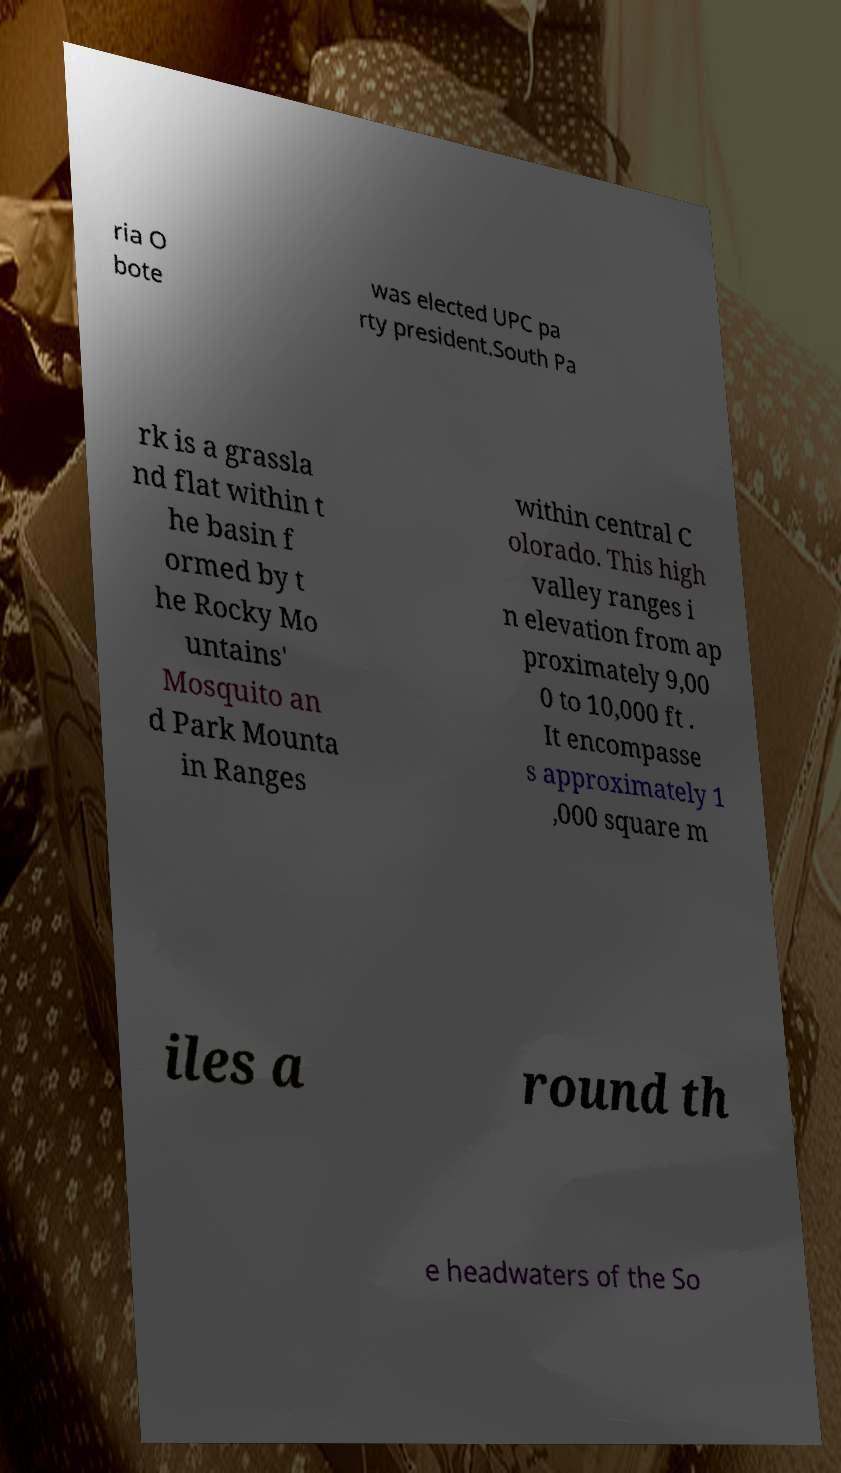I need the written content from this picture converted into text. Can you do that? ria O bote was elected UPC pa rty president.South Pa rk is a grassla nd flat within t he basin f ormed by t he Rocky Mo untains' Mosquito an d Park Mounta in Ranges within central C olorado. This high valley ranges i n elevation from ap proximately 9,00 0 to 10,000 ft . It encompasse s approximately 1 ,000 square m iles a round th e headwaters of the So 